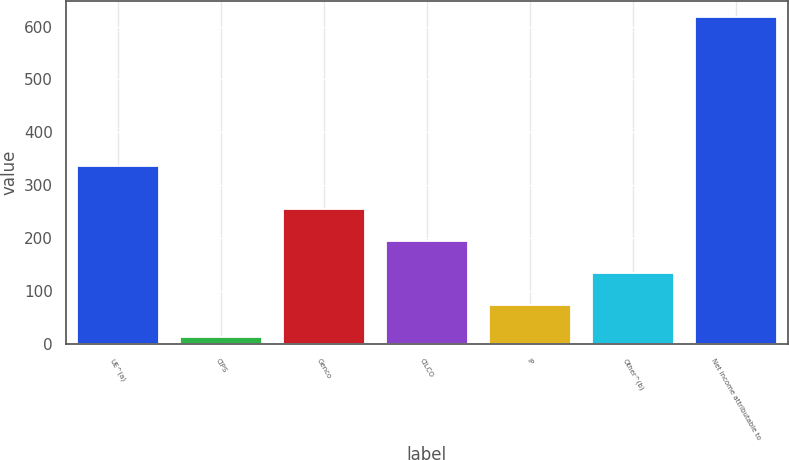<chart> <loc_0><loc_0><loc_500><loc_500><bar_chart><fcel>UE^(a)<fcel>CIPS<fcel>Genco<fcel>CILCO<fcel>IP<fcel>Other^(b)<fcel>Net income attributable to<nl><fcel>336<fcel>14<fcel>255.6<fcel>195.2<fcel>74.4<fcel>134.8<fcel>618<nl></chart> 